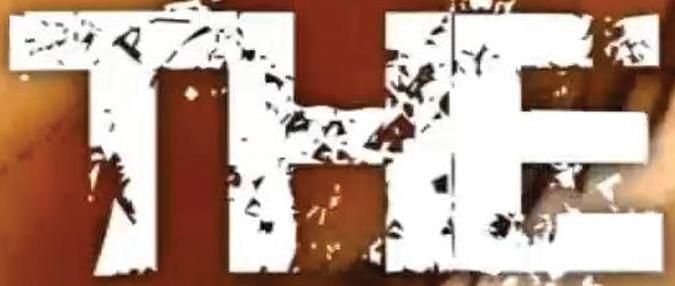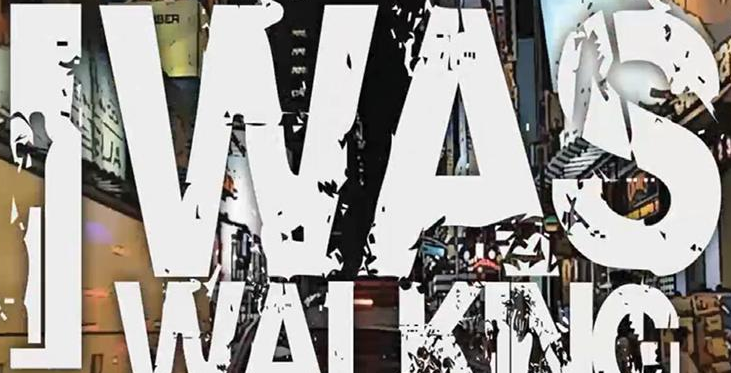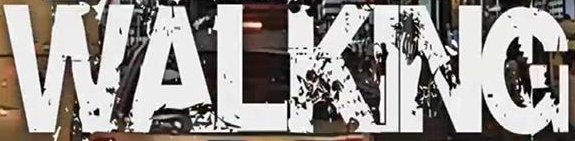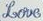Transcribe the words shown in these images in order, separated by a semicolon. THE; IWAS; WALKING; Love 